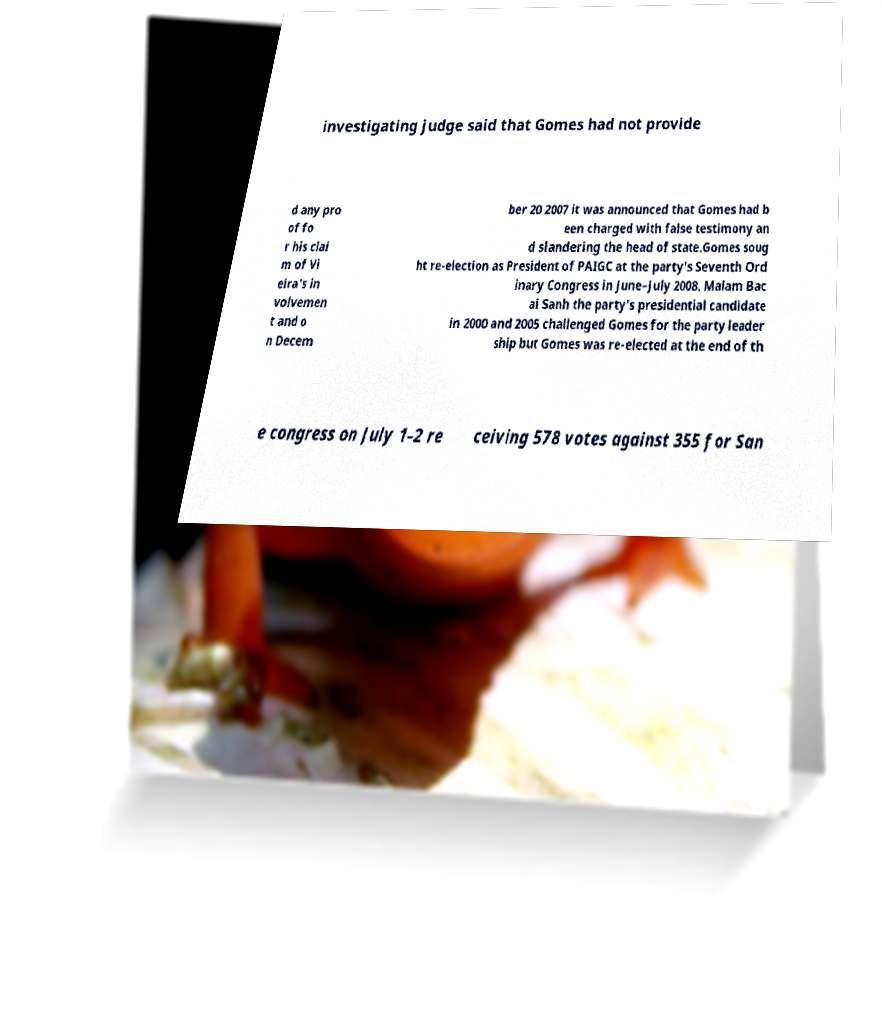Can you read and provide the text displayed in the image?This photo seems to have some interesting text. Can you extract and type it out for me? investigating judge said that Gomes had not provide d any pro of fo r his clai m of Vi eira's in volvemen t and o n Decem ber 20 2007 it was announced that Gomes had b een charged with false testimony an d slandering the head of state.Gomes soug ht re-election as President of PAIGC at the party's Seventh Ord inary Congress in June–July 2008. Malam Bac ai Sanh the party's presidential candidate in 2000 and 2005 challenged Gomes for the party leader ship but Gomes was re-elected at the end of th e congress on July 1–2 re ceiving 578 votes against 355 for San 